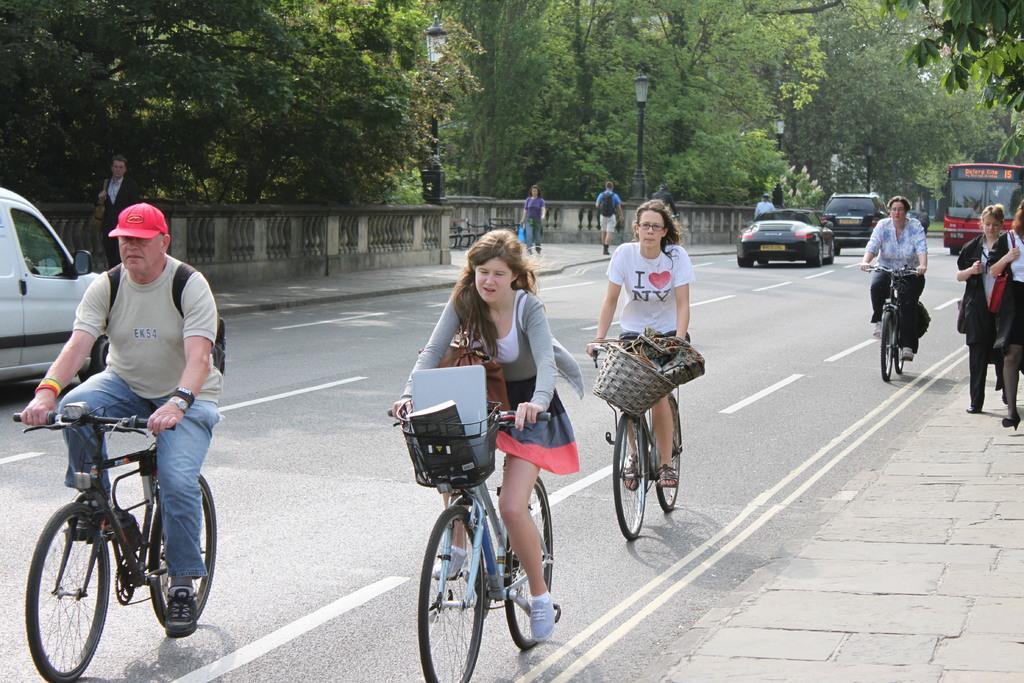Please provide a concise description of this image. Four people are riding their bicycles on a road. There are trees on the left side. 